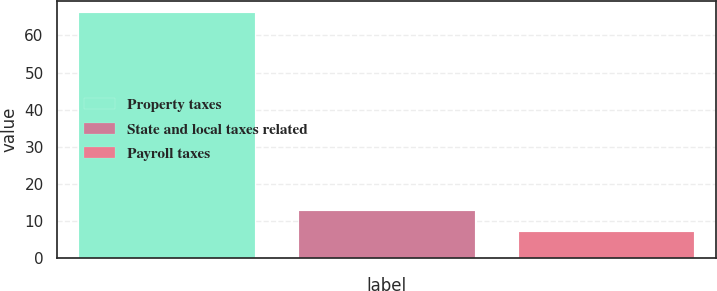<chart> <loc_0><loc_0><loc_500><loc_500><bar_chart><fcel>Property taxes<fcel>State and local taxes related<fcel>Payroll taxes<nl><fcel>66<fcel>12.9<fcel>7<nl></chart> 